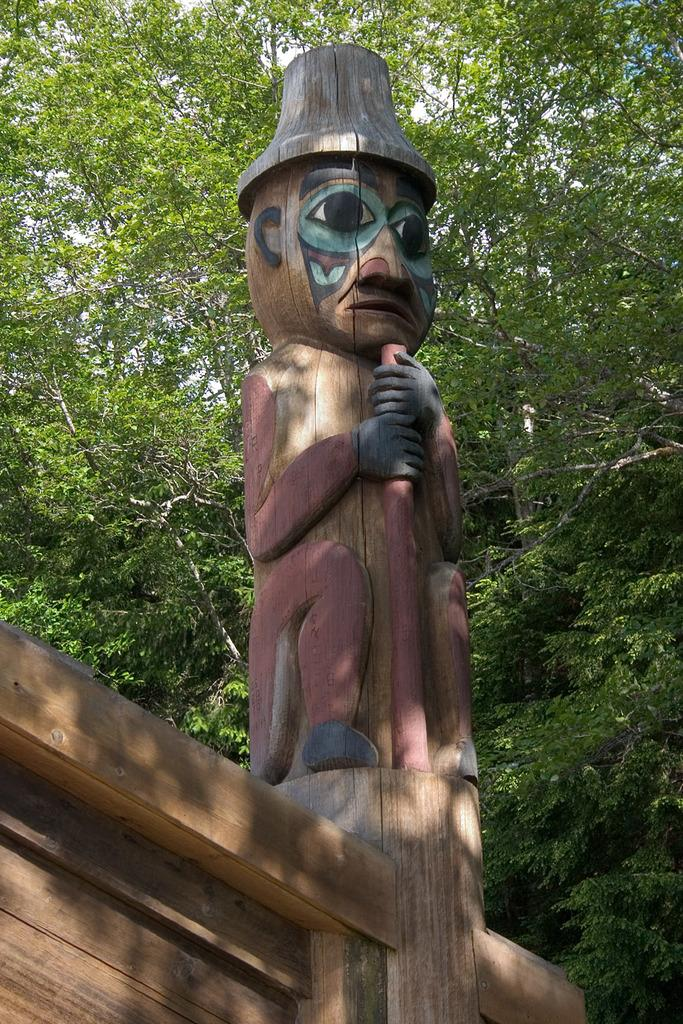What is the main subject in the image? There is a wooden sculpture in the image. What can be seen in the background of the image? There are trees and the sky visible in the background of the image. What type of planes can be seen flying in the image? There are no planes visible in the image; it features a wooden sculpture and trees in the background. What substance is being used to create the wooden sculpture in the image? The facts provided do not give information about the substance used to create the wooden sculpture, so it cannot be determined from the image. 